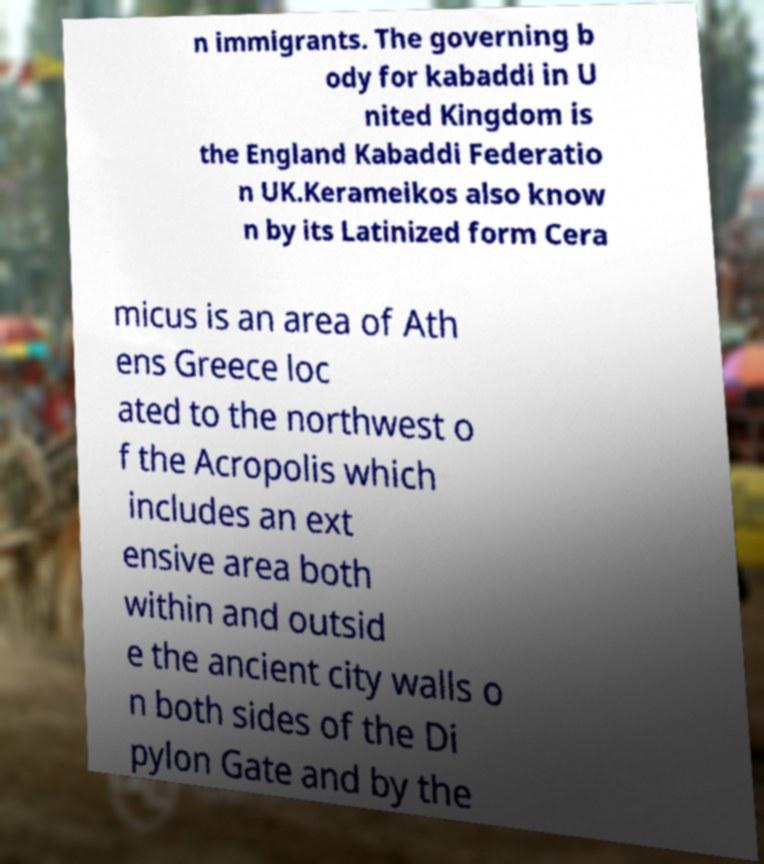For documentation purposes, I need the text within this image transcribed. Could you provide that? n immigrants. The governing b ody for kabaddi in U nited Kingdom is the England Kabaddi Federatio n UK.Kerameikos also know n by its Latinized form Cera micus is an area of Ath ens Greece loc ated to the northwest o f the Acropolis which includes an ext ensive area both within and outsid e the ancient city walls o n both sides of the Di pylon Gate and by the 